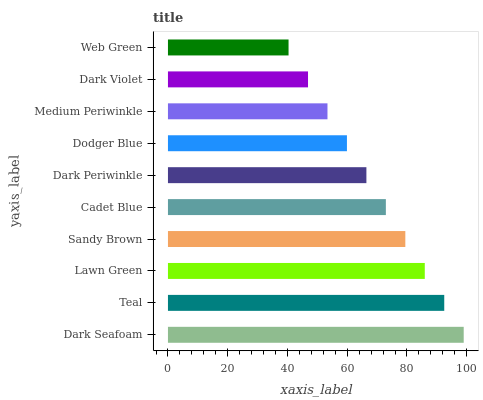Is Web Green the minimum?
Answer yes or no. Yes. Is Dark Seafoam the maximum?
Answer yes or no. Yes. Is Teal the minimum?
Answer yes or no. No. Is Teal the maximum?
Answer yes or no. No. Is Dark Seafoam greater than Teal?
Answer yes or no. Yes. Is Teal less than Dark Seafoam?
Answer yes or no. Yes. Is Teal greater than Dark Seafoam?
Answer yes or no. No. Is Dark Seafoam less than Teal?
Answer yes or no. No. Is Cadet Blue the high median?
Answer yes or no. Yes. Is Dark Periwinkle the low median?
Answer yes or no. Yes. Is Dark Violet the high median?
Answer yes or no. No. Is Teal the low median?
Answer yes or no. No. 